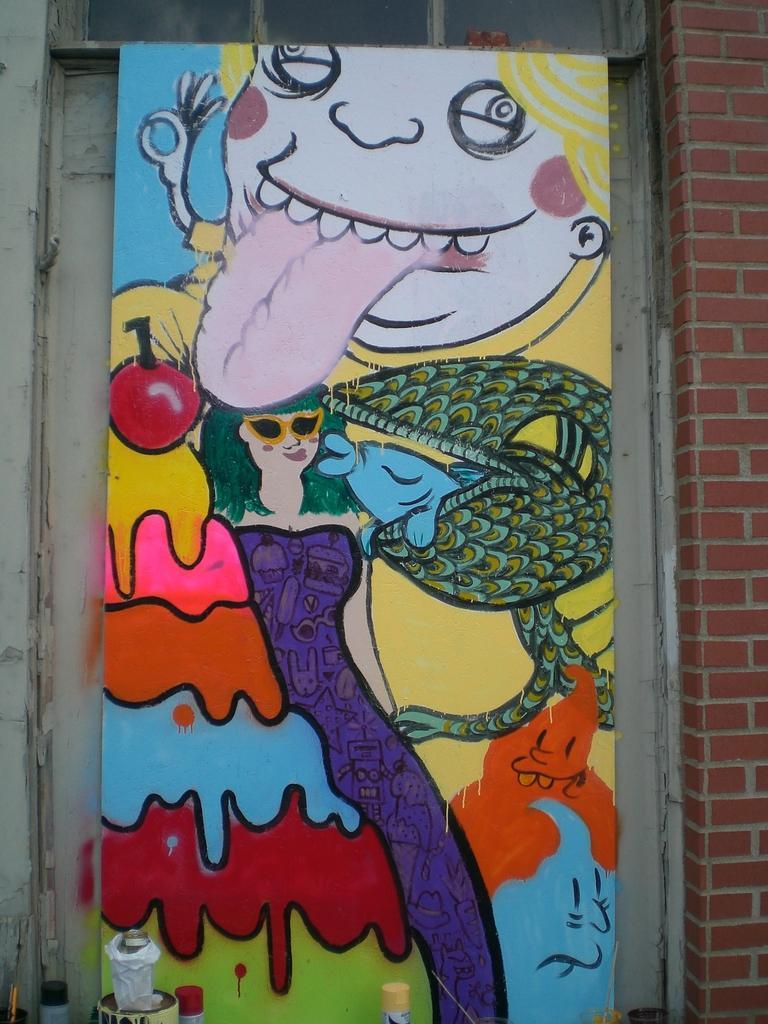How would you summarize this image in a sentence or two? In this image there is a board in the middle. On the board there is a painting. In the painting we can see that there is a girl in the middle. Beside her there is a fish. The board is kept near the wall. 